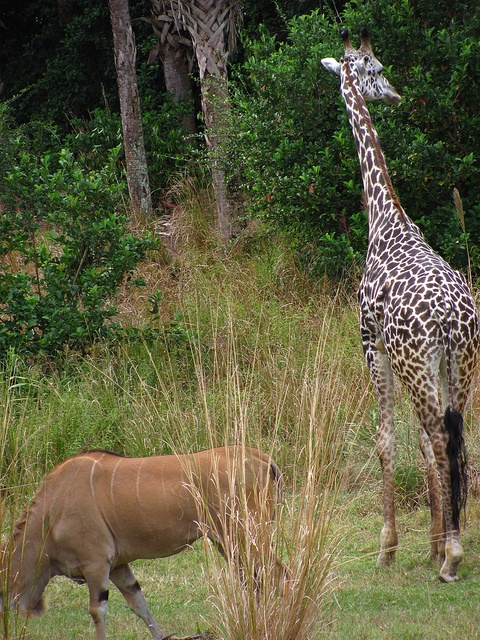Describe the objects in this image and their specific colors. I can see giraffe in black, gray, darkgray, and lightgray tones and horse in black, gray, maroon, and tan tones in this image. 